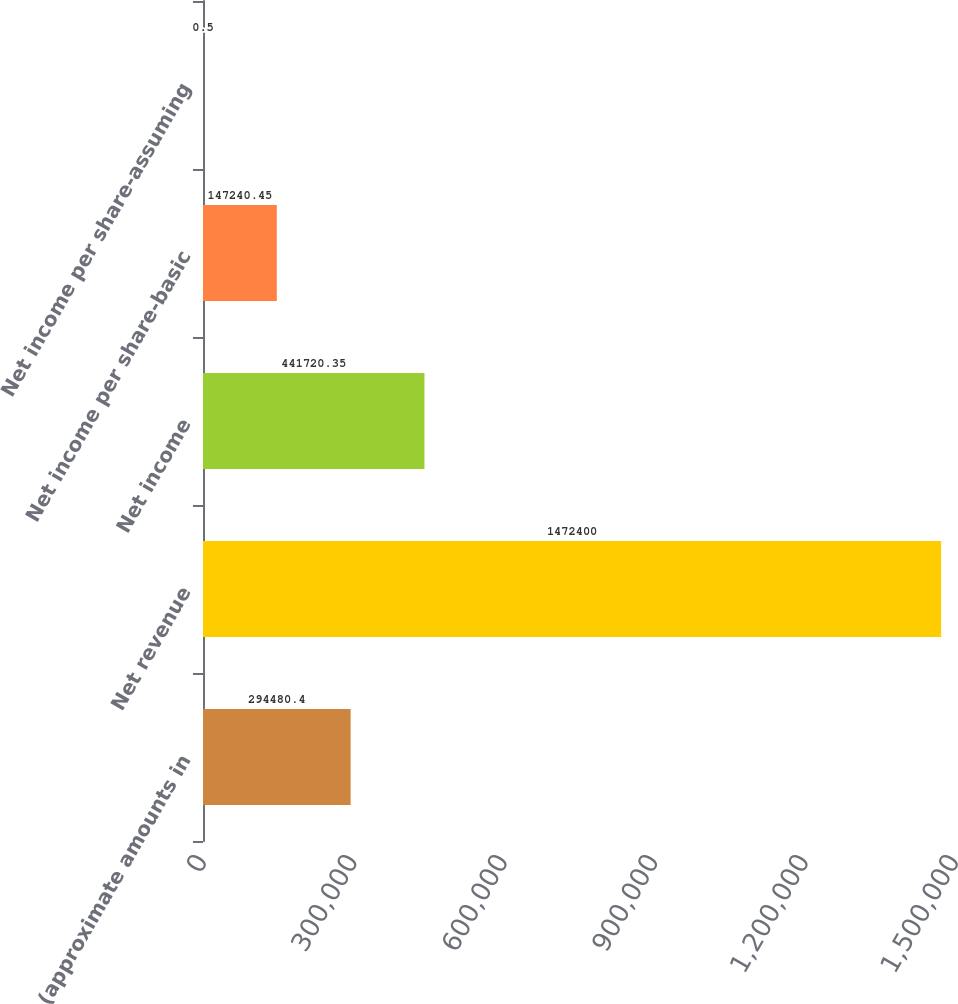<chart> <loc_0><loc_0><loc_500><loc_500><bar_chart><fcel>(approximate amounts in<fcel>Net revenue<fcel>Net income<fcel>Net income per share-basic<fcel>Net income per share-assuming<nl><fcel>294480<fcel>1.4724e+06<fcel>441720<fcel>147240<fcel>0.5<nl></chart> 